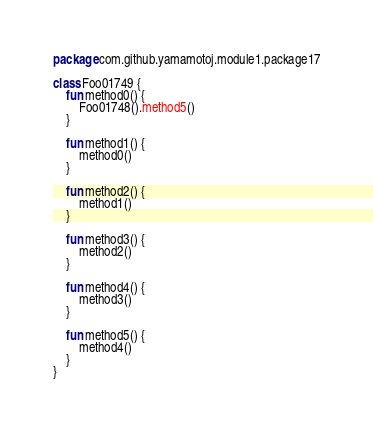<code> <loc_0><loc_0><loc_500><loc_500><_Kotlin_>package com.github.yamamotoj.module1.package17

class Foo01749 {
    fun method0() {
        Foo01748().method5()
    }

    fun method1() {
        method0()
    }

    fun method2() {
        method1()
    }

    fun method3() {
        method2()
    }

    fun method4() {
        method3()
    }

    fun method5() {
        method4()
    }
}
</code> 